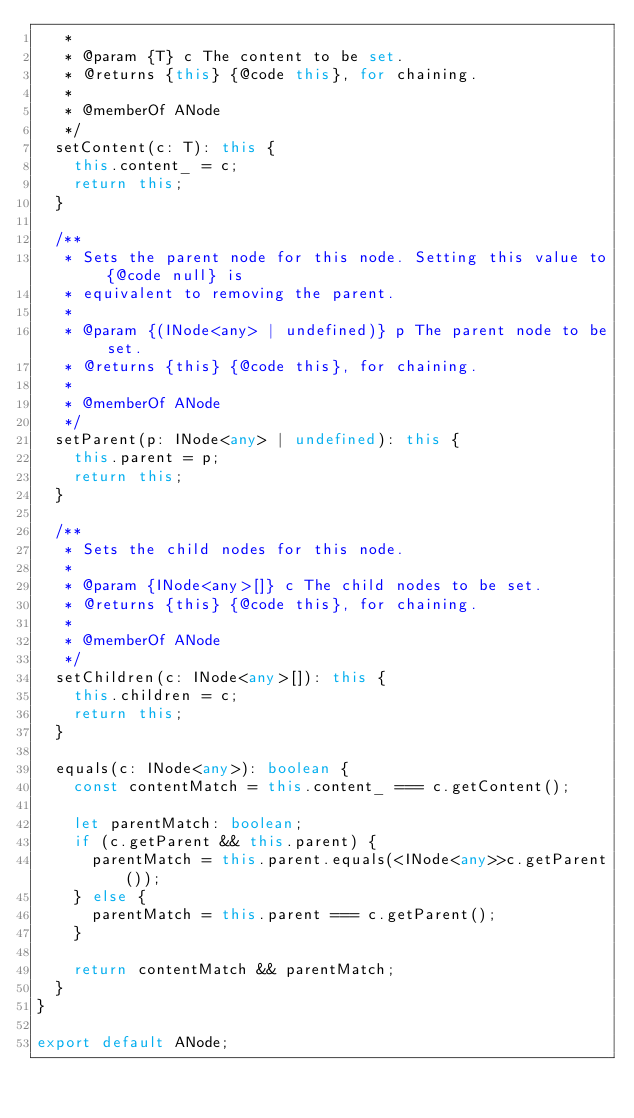<code> <loc_0><loc_0><loc_500><loc_500><_TypeScript_>   *
   * @param {T} c The content to be set.
   * @returns {this} {@code this}, for chaining.
   *
   * @memberOf ANode
   */
  setContent(c: T): this {
    this.content_ = c;
    return this;
  }

  /**
   * Sets the parent node for this node. Setting this value to {@code null} is
   * equivalent to removing the parent.
   *
   * @param {(INode<any> | undefined)} p The parent node to be set.
   * @returns {this} {@code this}, for chaining.
   *
   * @memberOf ANode
   */
  setParent(p: INode<any> | undefined): this {
    this.parent = p;
    return this;
  }

  /**
   * Sets the child nodes for this node.
   *
   * @param {INode<any>[]} c The child nodes to be set.
   * @returns {this} {@code this}, for chaining.
   *
   * @memberOf ANode
   */
  setChildren(c: INode<any>[]): this {
    this.children = c;
    return this;
  }

  equals(c: INode<any>): boolean {
    const contentMatch = this.content_ === c.getContent();

    let parentMatch: boolean;
    if (c.getParent && this.parent) {
      parentMatch = this.parent.equals(<INode<any>>c.getParent());
    } else {
      parentMatch = this.parent === c.getParent();
    }

    return contentMatch && parentMatch;
  }
}

export default ANode;
</code> 